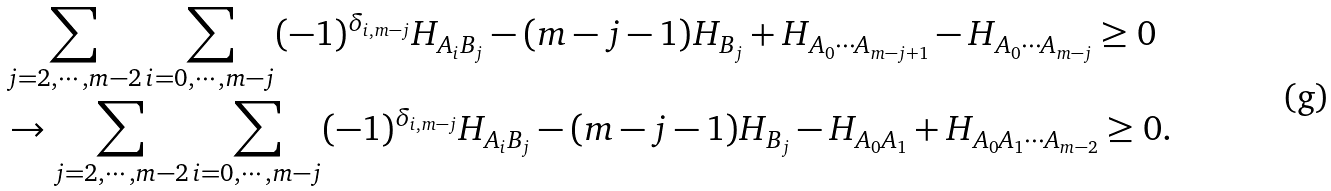Convert formula to latex. <formula><loc_0><loc_0><loc_500><loc_500>& \sum _ { j = 2 , \cdots , m - 2 } \sum _ { i = 0 , \cdots , m - j } ( - 1 ) ^ { \delta _ { i , m - j } } H _ { A _ { i } B _ { j } } - ( m - j - 1 ) H _ { B _ { j } } + H _ { A _ { 0 } \cdots A _ { m - j + 1 } } - H _ { A _ { 0 } \cdots A _ { m - j } } \geq 0 \\ & \rightarrow \sum _ { j = 2 , \cdots , m - 2 } \sum _ { i = 0 , \cdots , m - j } ( - 1 ) ^ { \delta _ { i , m - j } } H _ { A _ { i } B _ { j } } - ( m - j - 1 ) H _ { B _ { j } } - H _ { A _ { 0 } A _ { 1 } } + H _ { A _ { 0 } A _ { 1 } \cdots A _ { m - 2 } } \geq 0 .</formula> 